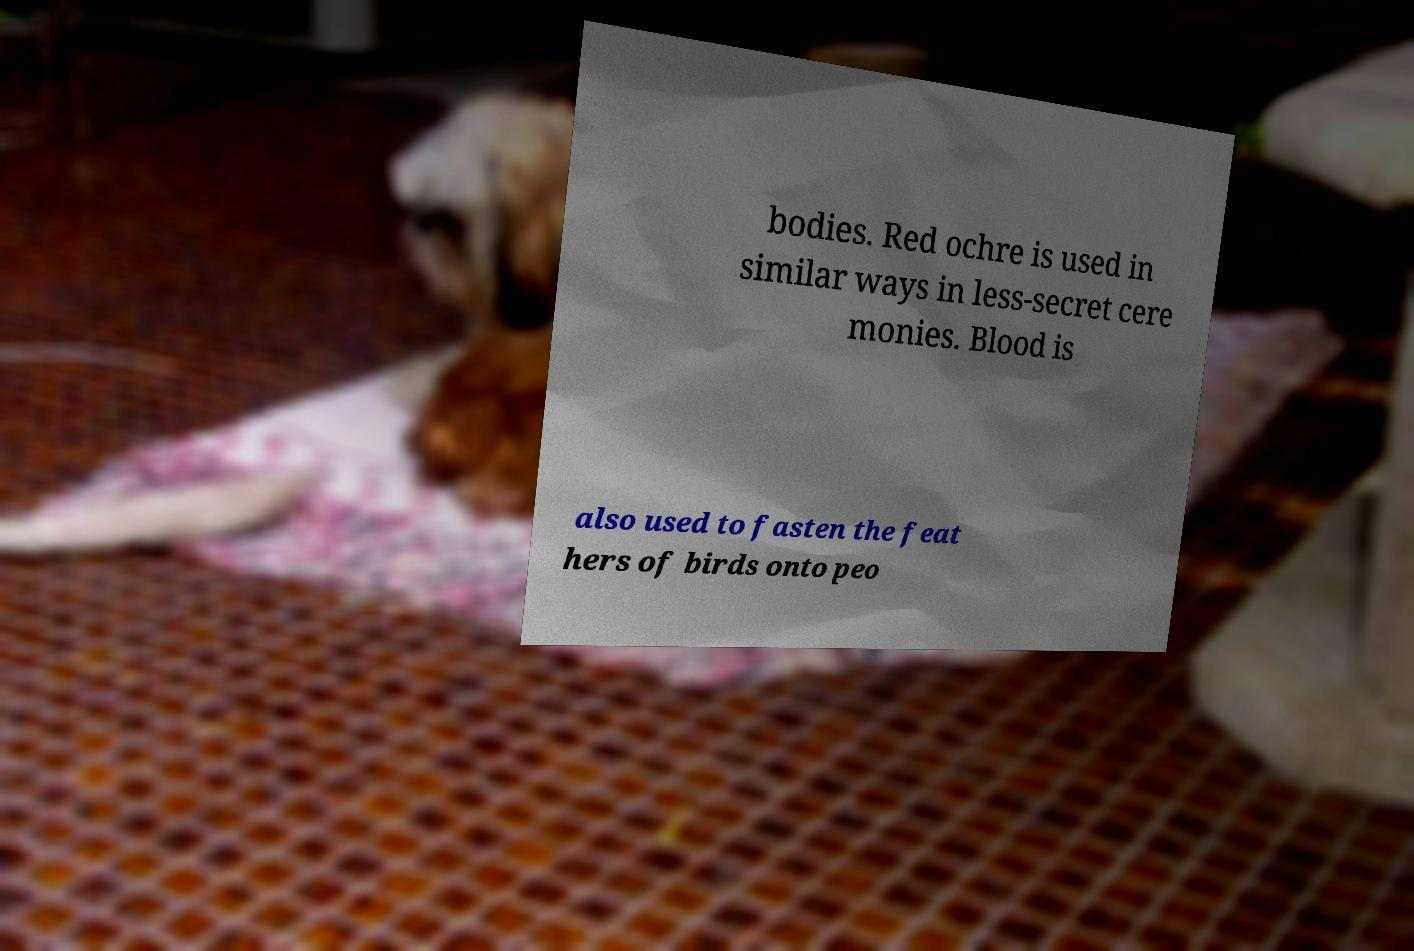Could you assist in decoding the text presented in this image and type it out clearly? bodies. Red ochre is used in similar ways in less-secret cere monies. Blood is also used to fasten the feat hers of birds onto peo 